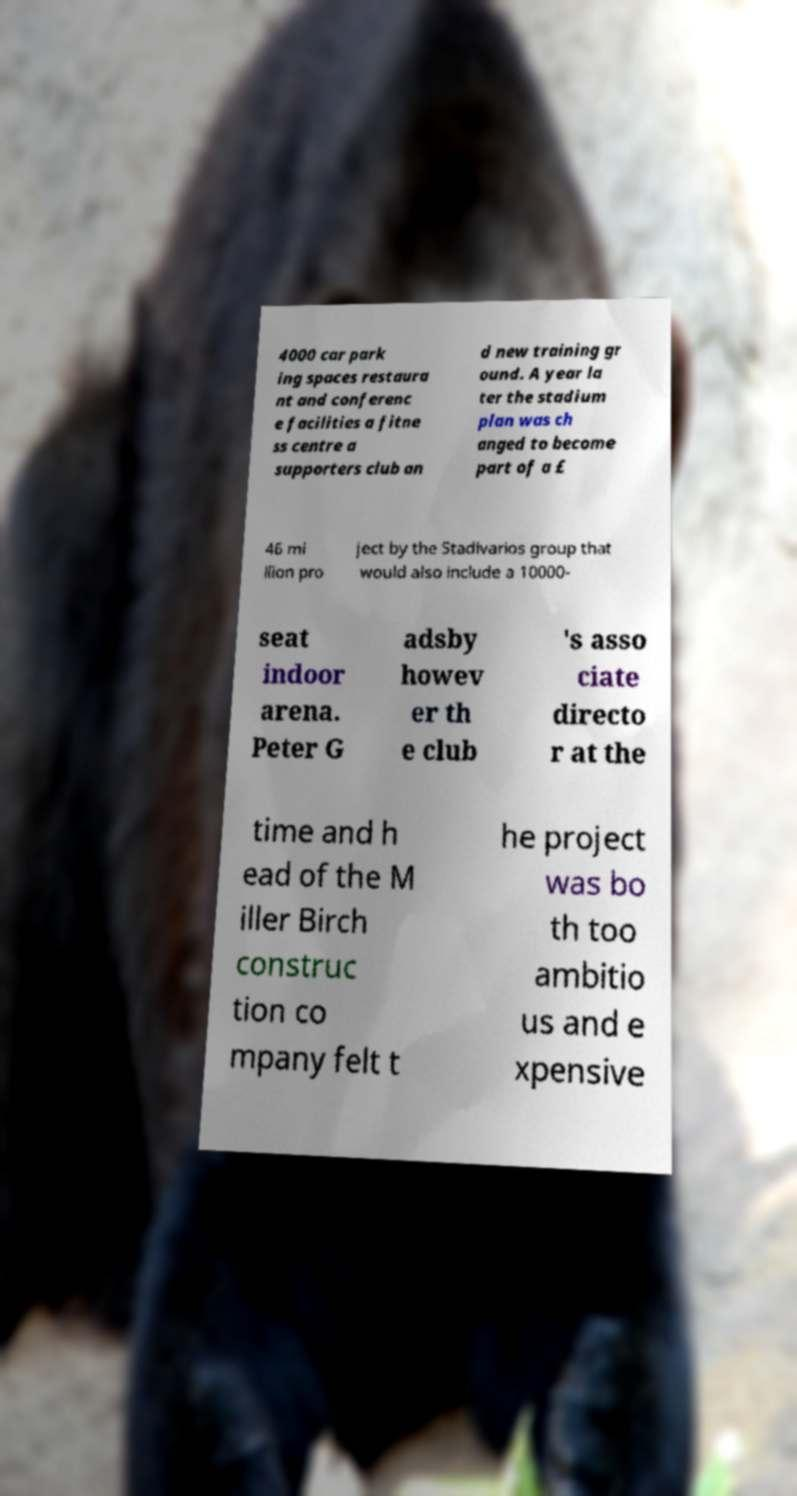Could you assist in decoding the text presented in this image and type it out clearly? 4000 car park ing spaces restaura nt and conferenc e facilities a fitne ss centre a supporters club an d new training gr ound. A year la ter the stadium plan was ch anged to become part of a £ 46 mi llion pro ject by the Stadivarios group that would also include a 10000- seat indoor arena. Peter G adsby howev er th e club 's asso ciate directo r at the time and h ead of the M iller Birch construc tion co mpany felt t he project was bo th too ambitio us and e xpensive 